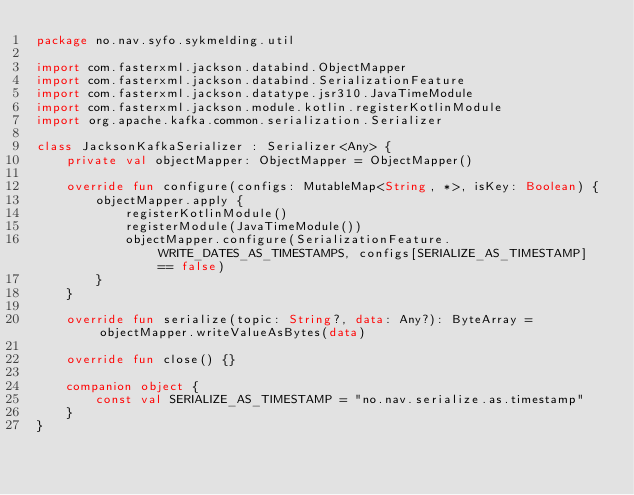Convert code to text. <code><loc_0><loc_0><loc_500><loc_500><_Kotlin_>package no.nav.syfo.sykmelding.util

import com.fasterxml.jackson.databind.ObjectMapper
import com.fasterxml.jackson.databind.SerializationFeature
import com.fasterxml.jackson.datatype.jsr310.JavaTimeModule
import com.fasterxml.jackson.module.kotlin.registerKotlinModule
import org.apache.kafka.common.serialization.Serializer

class JacksonKafkaSerializer : Serializer<Any> {
    private val objectMapper: ObjectMapper = ObjectMapper()

    override fun configure(configs: MutableMap<String, *>, isKey: Boolean) {
        objectMapper.apply {
            registerKotlinModule()
            registerModule(JavaTimeModule())
            objectMapper.configure(SerializationFeature.WRITE_DATES_AS_TIMESTAMPS, configs[SERIALIZE_AS_TIMESTAMP] == false)
        }
    }

    override fun serialize(topic: String?, data: Any?): ByteArray = objectMapper.writeValueAsBytes(data)

    override fun close() {}

    companion object {
        const val SERIALIZE_AS_TIMESTAMP = "no.nav.serialize.as.timestamp"
    }
}
</code> 